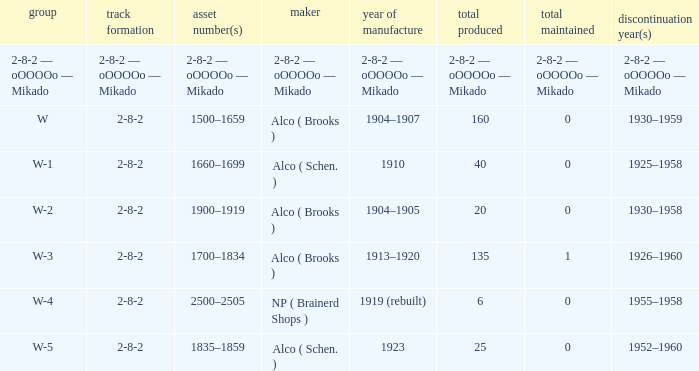What is the year retired of the locomotive which had the quantity made of 25? 1952–1960. 